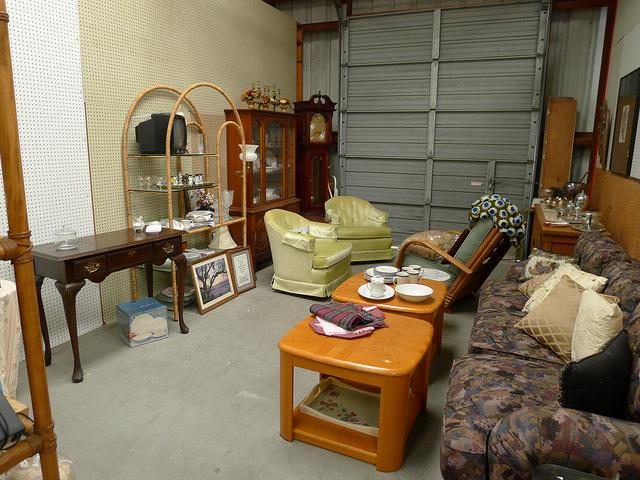Based on the door this furniture is most likely located in what?

Choices:
A) storage unit
B) living room
C) barn
D) bedroom storage unit 